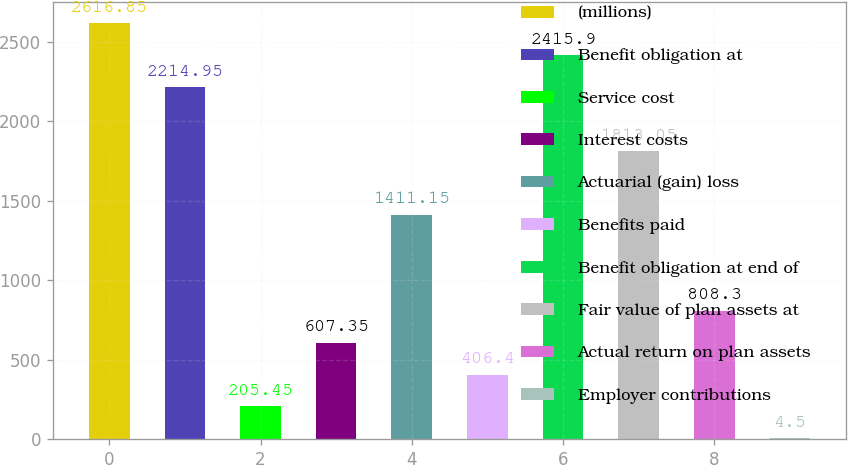Convert chart to OTSL. <chart><loc_0><loc_0><loc_500><loc_500><bar_chart><fcel>(millions)<fcel>Benefit obligation at<fcel>Service cost<fcel>Interest costs<fcel>Actuarial (gain) loss<fcel>Benefits paid<fcel>Benefit obligation at end of<fcel>Fair value of plan assets at<fcel>Actual return on plan assets<fcel>Employer contributions<nl><fcel>2616.85<fcel>2214.95<fcel>205.45<fcel>607.35<fcel>1411.15<fcel>406.4<fcel>2415.9<fcel>1813.05<fcel>808.3<fcel>4.5<nl></chart> 